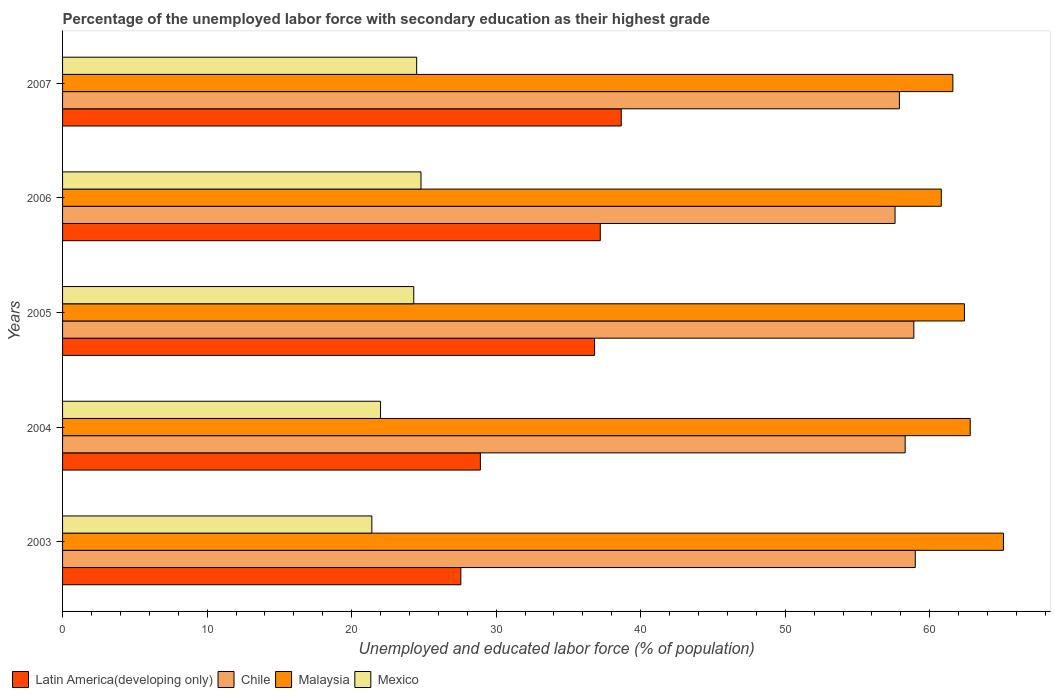How many groups of bars are there?
Offer a terse response. 5. Are the number of bars per tick equal to the number of legend labels?
Provide a succinct answer. Yes. What is the label of the 4th group of bars from the top?
Offer a terse response. 2004. What is the percentage of the unemployed labor force with secondary education in Latin America(developing only) in 2004?
Your answer should be very brief. 28.91. Across all years, what is the maximum percentage of the unemployed labor force with secondary education in Chile?
Make the answer very short. 59. Across all years, what is the minimum percentage of the unemployed labor force with secondary education in Malaysia?
Provide a short and direct response. 60.8. In which year was the percentage of the unemployed labor force with secondary education in Chile minimum?
Provide a short and direct response. 2006. What is the total percentage of the unemployed labor force with secondary education in Chile in the graph?
Offer a terse response. 291.7. What is the difference between the percentage of the unemployed labor force with secondary education in Chile in 2004 and that in 2006?
Keep it short and to the point. 0.7. What is the difference between the percentage of the unemployed labor force with secondary education in Latin America(developing only) in 2005 and the percentage of the unemployed labor force with secondary education in Chile in 2003?
Give a very brief answer. -22.19. What is the average percentage of the unemployed labor force with secondary education in Chile per year?
Offer a very short reply. 58.34. In the year 2005, what is the difference between the percentage of the unemployed labor force with secondary education in Mexico and percentage of the unemployed labor force with secondary education in Latin America(developing only)?
Ensure brevity in your answer.  -12.51. What is the ratio of the percentage of the unemployed labor force with secondary education in Chile in 2005 to that in 2007?
Keep it short and to the point. 1.02. Is the percentage of the unemployed labor force with secondary education in Mexico in 2003 less than that in 2005?
Your response must be concise. Yes. What is the difference between the highest and the second highest percentage of the unemployed labor force with secondary education in Chile?
Your answer should be compact. 0.1. What is the difference between the highest and the lowest percentage of the unemployed labor force with secondary education in Latin America(developing only)?
Your answer should be very brief. 11.1. Is it the case that in every year, the sum of the percentage of the unemployed labor force with secondary education in Malaysia and percentage of the unemployed labor force with secondary education in Chile is greater than the sum of percentage of the unemployed labor force with secondary education in Mexico and percentage of the unemployed labor force with secondary education in Latin America(developing only)?
Give a very brief answer. Yes. What does the 3rd bar from the top in 2005 represents?
Provide a short and direct response. Chile. What does the 1st bar from the bottom in 2005 represents?
Your answer should be compact. Latin America(developing only). How many bars are there?
Offer a very short reply. 20. Are all the bars in the graph horizontal?
Offer a very short reply. Yes. Are the values on the major ticks of X-axis written in scientific E-notation?
Keep it short and to the point. No. Does the graph contain grids?
Make the answer very short. No. How many legend labels are there?
Your answer should be very brief. 4. What is the title of the graph?
Provide a short and direct response. Percentage of the unemployed labor force with secondary education as their highest grade. Does "Gambia, The" appear as one of the legend labels in the graph?
Offer a terse response. No. What is the label or title of the X-axis?
Give a very brief answer. Unemployed and educated labor force (% of population). What is the Unemployed and educated labor force (% of population) in Latin America(developing only) in 2003?
Provide a succinct answer. 27.56. What is the Unemployed and educated labor force (% of population) of Malaysia in 2003?
Keep it short and to the point. 65.1. What is the Unemployed and educated labor force (% of population) of Mexico in 2003?
Your answer should be very brief. 21.4. What is the Unemployed and educated labor force (% of population) of Latin America(developing only) in 2004?
Offer a very short reply. 28.91. What is the Unemployed and educated labor force (% of population) in Chile in 2004?
Ensure brevity in your answer.  58.3. What is the Unemployed and educated labor force (% of population) of Malaysia in 2004?
Your answer should be very brief. 62.8. What is the Unemployed and educated labor force (% of population) in Latin America(developing only) in 2005?
Offer a very short reply. 36.81. What is the Unemployed and educated labor force (% of population) in Chile in 2005?
Your answer should be compact. 58.9. What is the Unemployed and educated labor force (% of population) in Malaysia in 2005?
Keep it short and to the point. 62.4. What is the Unemployed and educated labor force (% of population) in Mexico in 2005?
Offer a very short reply. 24.3. What is the Unemployed and educated labor force (% of population) in Latin America(developing only) in 2006?
Offer a very short reply. 37.21. What is the Unemployed and educated labor force (% of population) in Chile in 2006?
Ensure brevity in your answer.  57.6. What is the Unemployed and educated labor force (% of population) of Malaysia in 2006?
Your response must be concise. 60.8. What is the Unemployed and educated labor force (% of population) of Mexico in 2006?
Your response must be concise. 24.8. What is the Unemployed and educated labor force (% of population) of Latin America(developing only) in 2007?
Your answer should be very brief. 38.66. What is the Unemployed and educated labor force (% of population) in Chile in 2007?
Offer a very short reply. 57.9. What is the Unemployed and educated labor force (% of population) in Malaysia in 2007?
Your answer should be very brief. 61.6. Across all years, what is the maximum Unemployed and educated labor force (% of population) of Latin America(developing only)?
Your answer should be very brief. 38.66. Across all years, what is the maximum Unemployed and educated labor force (% of population) in Malaysia?
Give a very brief answer. 65.1. Across all years, what is the maximum Unemployed and educated labor force (% of population) in Mexico?
Keep it short and to the point. 24.8. Across all years, what is the minimum Unemployed and educated labor force (% of population) in Latin America(developing only)?
Give a very brief answer. 27.56. Across all years, what is the minimum Unemployed and educated labor force (% of population) in Chile?
Offer a very short reply. 57.6. Across all years, what is the minimum Unemployed and educated labor force (% of population) of Malaysia?
Your answer should be compact. 60.8. Across all years, what is the minimum Unemployed and educated labor force (% of population) of Mexico?
Provide a succinct answer. 21.4. What is the total Unemployed and educated labor force (% of population) of Latin America(developing only) in the graph?
Keep it short and to the point. 169.14. What is the total Unemployed and educated labor force (% of population) in Chile in the graph?
Make the answer very short. 291.7. What is the total Unemployed and educated labor force (% of population) of Malaysia in the graph?
Provide a short and direct response. 312.7. What is the total Unemployed and educated labor force (% of population) of Mexico in the graph?
Offer a very short reply. 117. What is the difference between the Unemployed and educated labor force (% of population) of Latin America(developing only) in 2003 and that in 2004?
Your response must be concise. -1.35. What is the difference between the Unemployed and educated labor force (% of population) in Malaysia in 2003 and that in 2004?
Ensure brevity in your answer.  2.3. What is the difference between the Unemployed and educated labor force (% of population) in Mexico in 2003 and that in 2004?
Keep it short and to the point. -0.6. What is the difference between the Unemployed and educated labor force (% of population) in Latin America(developing only) in 2003 and that in 2005?
Offer a very short reply. -9.25. What is the difference between the Unemployed and educated labor force (% of population) in Latin America(developing only) in 2003 and that in 2006?
Provide a succinct answer. -9.65. What is the difference between the Unemployed and educated labor force (% of population) of Chile in 2003 and that in 2006?
Offer a very short reply. 1.4. What is the difference between the Unemployed and educated labor force (% of population) in Malaysia in 2003 and that in 2006?
Make the answer very short. 4.3. What is the difference between the Unemployed and educated labor force (% of population) of Latin America(developing only) in 2003 and that in 2007?
Provide a succinct answer. -11.1. What is the difference between the Unemployed and educated labor force (% of population) in Chile in 2003 and that in 2007?
Offer a terse response. 1.1. What is the difference between the Unemployed and educated labor force (% of population) of Mexico in 2003 and that in 2007?
Make the answer very short. -3.1. What is the difference between the Unemployed and educated labor force (% of population) of Latin America(developing only) in 2004 and that in 2005?
Make the answer very short. -7.9. What is the difference between the Unemployed and educated labor force (% of population) in Malaysia in 2004 and that in 2005?
Ensure brevity in your answer.  0.4. What is the difference between the Unemployed and educated labor force (% of population) in Latin America(developing only) in 2004 and that in 2006?
Offer a very short reply. -8.3. What is the difference between the Unemployed and educated labor force (% of population) in Chile in 2004 and that in 2006?
Offer a terse response. 0.7. What is the difference between the Unemployed and educated labor force (% of population) in Malaysia in 2004 and that in 2006?
Give a very brief answer. 2. What is the difference between the Unemployed and educated labor force (% of population) in Mexico in 2004 and that in 2006?
Keep it short and to the point. -2.8. What is the difference between the Unemployed and educated labor force (% of population) of Latin America(developing only) in 2004 and that in 2007?
Ensure brevity in your answer.  -9.75. What is the difference between the Unemployed and educated labor force (% of population) of Latin America(developing only) in 2005 and that in 2006?
Offer a terse response. -0.39. What is the difference between the Unemployed and educated labor force (% of population) in Mexico in 2005 and that in 2006?
Your response must be concise. -0.5. What is the difference between the Unemployed and educated labor force (% of population) of Latin America(developing only) in 2005 and that in 2007?
Keep it short and to the point. -1.84. What is the difference between the Unemployed and educated labor force (% of population) in Mexico in 2005 and that in 2007?
Make the answer very short. -0.2. What is the difference between the Unemployed and educated labor force (% of population) of Latin America(developing only) in 2006 and that in 2007?
Ensure brevity in your answer.  -1.45. What is the difference between the Unemployed and educated labor force (% of population) in Malaysia in 2006 and that in 2007?
Your answer should be compact. -0.8. What is the difference between the Unemployed and educated labor force (% of population) of Latin America(developing only) in 2003 and the Unemployed and educated labor force (% of population) of Chile in 2004?
Provide a succinct answer. -30.74. What is the difference between the Unemployed and educated labor force (% of population) of Latin America(developing only) in 2003 and the Unemployed and educated labor force (% of population) of Malaysia in 2004?
Offer a terse response. -35.24. What is the difference between the Unemployed and educated labor force (% of population) of Latin America(developing only) in 2003 and the Unemployed and educated labor force (% of population) of Mexico in 2004?
Ensure brevity in your answer.  5.56. What is the difference between the Unemployed and educated labor force (% of population) in Malaysia in 2003 and the Unemployed and educated labor force (% of population) in Mexico in 2004?
Make the answer very short. 43.1. What is the difference between the Unemployed and educated labor force (% of population) of Latin America(developing only) in 2003 and the Unemployed and educated labor force (% of population) of Chile in 2005?
Provide a succinct answer. -31.34. What is the difference between the Unemployed and educated labor force (% of population) of Latin America(developing only) in 2003 and the Unemployed and educated labor force (% of population) of Malaysia in 2005?
Ensure brevity in your answer.  -34.84. What is the difference between the Unemployed and educated labor force (% of population) of Latin America(developing only) in 2003 and the Unemployed and educated labor force (% of population) of Mexico in 2005?
Make the answer very short. 3.26. What is the difference between the Unemployed and educated labor force (% of population) of Chile in 2003 and the Unemployed and educated labor force (% of population) of Malaysia in 2005?
Your response must be concise. -3.4. What is the difference between the Unemployed and educated labor force (% of population) of Chile in 2003 and the Unemployed and educated labor force (% of population) of Mexico in 2005?
Make the answer very short. 34.7. What is the difference between the Unemployed and educated labor force (% of population) of Malaysia in 2003 and the Unemployed and educated labor force (% of population) of Mexico in 2005?
Your response must be concise. 40.8. What is the difference between the Unemployed and educated labor force (% of population) of Latin America(developing only) in 2003 and the Unemployed and educated labor force (% of population) of Chile in 2006?
Provide a succinct answer. -30.04. What is the difference between the Unemployed and educated labor force (% of population) of Latin America(developing only) in 2003 and the Unemployed and educated labor force (% of population) of Malaysia in 2006?
Ensure brevity in your answer.  -33.24. What is the difference between the Unemployed and educated labor force (% of population) in Latin America(developing only) in 2003 and the Unemployed and educated labor force (% of population) in Mexico in 2006?
Make the answer very short. 2.76. What is the difference between the Unemployed and educated labor force (% of population) of Chile in 2003 and the Unemployed and educated labor force (% of population) of Mexico in 2006?
Provide a succinct answer. 34.2. What is the difference between the Unemployed and educated labor force (% of population) in Malaysia in 2003 and the Unemployed and educated labor force (% of population) in Mexico in 2006?
Offer a very short reply. 40.3. What is the difference between the Unemployed and educated labor force (% of population) in Latin America(developing only) in 2003 and the Unemployed and educated labor force (% of population) in Chile in 2007?
Your response must be concise. -30.34. What is the difference between the Unemployed and educated labor force (% of population) in Latin America(developing only) in 2003 and the Unemployed and educated labor force (% of population) in Malaysia in 2007?
Provide a succinct answer. -34.04. What is the difference between the Unemployed and educated labor force (% of population) in Latin America(developing only) in 2003 and the Unemployed and educated labor force (% of population) in Mexico in 2007?
Provide a succinct answer. 3.06. What is the difference between the Unemployed and educated labor force (% of population) of Chile in 2003 and the Unemployed and educated labor force (% of population) of Mexico in 2007?
Provide a succinct answer. 34.5. What is the difference between the Unemployed and educated labor force (% of population) in Malaysia in 2003 and the Unemployed and educated labor force (% of population) in Mexico in 2007?
Offer a very short reply. 40.6. What is the difference between the Unemployed and educated labor force (% of population) in Latin America(developing only) in 2004 and the Unemployed and educated labor force (% of population) in Chile in 2005?
Your answer should be compact. -29.99. What is the difference between the Unemployed and educated labor force (% of population) of Latin America(developing only) in 2004 and the Unemployed and educated labor force (% of population) of Malaysia in 2005?
Offer a very short reply. -33.49. What is the difference between the Unemployed and educated labor force (% of population) of Latin America(developing only) in 2004 and the Unemployed and educated labor force (% of population) of Mexico in 2005?
Offer a very short reply. 4.61. What is the difference between the Unemployed and educated labor force (% of population) of Malaysia in 2004 and the Unemployed and educated labor force (% of population) of Mexico in 2005?
Ensure brevity in your answer.  38.5. What is the difference between the Unemployed and educated labor force (% of population) in Latin America(developing only) in 2004 and the Unemployed and educated labor force (% of population) in Chile in 2006?
Make the answer very short. -28.69. What is the difference between the Unemployed and educated labor force (% of population) in Latin America(developing only) in 2004 and the Unemployed and educated labor force (% of population) in Malaysia in 2006?
Give a very brief answer. -31.89. What is the difference between the Unemployed and educated labor force (% of population) in Latin America(developing only) in 2004 and the Unemployed and educated labor force (% of population) in Mexico in 2006?
Keep it short and to the point. 4.11. What is the difference between the Unemployed and educated labor force (% of population) of Chile in 2004 and the Unemployed and educated labor force (% of population) of Malaysia in 2006?
Give a very brief answer. -2.5. What is the difference between the Unemployed and educated labor force (% of population) in Chile in 2004 and the Unemployed and educated labor force (% of population) in Mexico in 2006?
Provide a short and direct response. 33.5. What is the difference between the Unemployed and educated labor force (% of population) in Latin America(developing only) in 2004 and the Unemployed and educated labor force (% of population) in Chile in 2007?
Provide a short and direct response. -28.99. What is the difference between the Unemployed and educated labor force (% of population) of Latin America(developing only) in 2004 and the Unemployed and educated labor force (% of population) of Malaysia in 2007?
Your answer should be compact. -32.69. What is the difference between the Unemployed and educated labor force (% of population) in Latin America(developing only) in 2004 and the Unemployed and educated labor force (% of population) in Mexico in 2007?
Make the answer very short. 4.41. What is the difference between the Unemployed and educated labor force (% of population) in Chile in 2004 and the Unemployed and educated labor force (% of population) in Mexico in 2007?
Your answer should be very brief. 33.8. What is the difference between the Unemployed and educated labor force (% of population) in Malaysia in 2004 and the Unemployed and educated labor force (% of population) in Mexico in 2007?
Ensure brevity in your answer.  38.3. What is the difference between the Unemployed and educated labor force (% of population) of Latin America(developing only) in 2005 and the Unemployed and educated labor force (% of population) of Chile in 2006?
Your answer should be compact. -20.79. What is the difference between the Unemployed and educated labor force (% of population) in Latin America(developing only) in 2005 and the Unemployed and educated labor force (% of population) in Malaysia in 2006?
Provide a succinct answer. -23.99. What is the difference between the Unemployed and educated labor force (% of population) in Latin America(developing only) in 2005 and the Unemployed and educated labor force (% of population) in Mexico in 2006?
Offer a terse response. 12.01. What is the difference between the Unemployed and educated labor force (% of population) of Chile in 2005 and the Unemployed and educated labor force (% of population) of Mexico in 2006?
Your response must be concise. 34.1. What is the difference between the Unemployed and educated labor force (% of population) in Malaysia in 2005 and the Unemployed and educated labor force (% of population) in Mexico in 2006?
Your answer should be very brief. 37.6. What is the difference between the Unemployed and educated labor force (% of population) of Latin America(developing only) in 2005 and the Unemployed and educated labor force (% of population) of Chile in 2007?
Keep it short and to the point. -21.09. What is the difference between the Unemployed and educated labor force (% of population) in Latin America(developing only) in 2005 and the Unemployed and educated labor force (% of population) in Malaysia in 2007?
Offer a terse response. -24.79. What is the difference between the Unemployed and educated labor force (% of population) of Latin America(developing only) in 2005 and the Unemployed and educated labor force (% of population) of Mexico in 2007?
Your answer should be very brief. 12.31. What is the difference between the Unemployed and educated labor force (% of population) in Chile in 2005 and the Unemployed and educated labor force (% of population) in Mexico in 2007?
Your answer should be compact. 34.4. What is the difference between the Unemployed and educated labor force (% of population) in Malaysia in 2005 and the Unemployed and educated labor force (% of population) in Mexico in 2007?
Keep it short and to the point. 37.9. What is the difference between the Unemployed and educated labor force (% of population) of Latin America(developing only) in 2006 and the Unemployed and educated labor force (% of population) of Chile in 2007?
Provide a short and direct response. -20.69. What is the difference between the Unemployed and educated labor force (% of population) of Latin America(developing only) in 2006 and the Unemployed and educated labor force (% of population) of Malaysia in 2007?
Ensure brevity in your answer.  -24.39. What is the difference between the Unemployed and educated labor force (% of population) in Latin America(developing only) in 2006 and the Unemployed and educated labor force (% of population) in Mexico in 2007?
Offer a terse response. 12.71. What is the difference between the Unemployed and educated labor force (% of population) in Chile in 2006 and the Unemployed and educated labor force (% of population) in Mexico in 2007?
Make the answer very short. 33.1. What is the difference between the Unemployed and educated labor force (% of population) of Malaysia in 2006 and the Unemployed and educated labor force (% of population) of Mexico in 2007?
Ensure brevity in your answer.  36.3. What is the average Unemployed and educated labor force (% of population) of Latin America(developing only) per year?
Keep it short and to the point. 33.83. What is the average Unemployed and educated labor force (% of population) in Chile per year?
Your answer should be very brief. 58.34. What is the average Unemployed and educated labor force (% of population) of Malaysia per year?
Make the answer very short. 62.54. What is the average Unemployed and educated labor force (% of population) in Mexico per year?
Ensure brevity in your answer.  23.4. In the year 2003, what is the difference between the Unemployed and educated labor force (% of population) in Latin America(developing only) and Unemployed and educated labor force (% of population) in Chile?
Ensure brevity in your answer.  -31.44. In the year 2003, what is the difference between the Unemployed and educated labor force (% of population) in Latin America(developing only) and Unemployed and educated labor force (% of population) in Malaysia?
Your answer should be very brief. -37.54. In the year 2003, what is the difference between the Unemployed and educated labor force (% of population) of Latin America(developing only) and Unemployed and educated labor force (% of population) of Mexico?
Your answer should be compact. 6.16. In the year 2003, what is the difference between the Unemployed and educated labor force (% of population) of Chile and Unemployed and educated labor force (% of population) of Mexico?
Provide a short and direct response. 37.6. In the year 2003, what is the difference between the Unemployed and educated labor force (% of population) in Malaysia and Unemployed and educated labor force (% of population) in Mexico?
Keep it short and to the point. 43.7. In the year 2004, what is the difference between the Unemployed and educated labor force (% of population) in Latin America(developing only) and Unemployed and educated labor force (% of population) in Chile?
Offer a very short reply. -29.39. In the year 2004, what is the difference between the Unemployed and educated labor force (% of population) of Latin America(developing only) and Unemployed and educated labor force (% of population) of Malaysia?
Give a very brief answer. -33.89. In the year 2004, what is the difference between the Unemployed and educated labor force (% of population) of Latin America(developing only) and Unemployed and educated labor force (% of population) of Mexico?
Keep it short and to the point. 6.91. In the year 2004, what is the difference between the Unemployed and educated labor force (% of population) of Chile and Unemployed and educated labor force (% of population) of Mexico?
Provide a succinct answer. 36.3. In the year 2004, what is the difference between the Unemployed and educated labor force (% of population) of Malaysia and Unemployed and educated labor force (% of population) of Mexico?
Your response must be concise. 40.8. In the year 2005, what is the difference between the Unemployed and educated labor force (% of population) in Latin America(developing only) and Unemployed and educated labor force (% of population) in Chile?
Your answer should be compact. -22.09. In the year 2005, what is the difference between the Unemployed and educated labor force (% of population) of Latin America(developing only) and Unemployed and educated labor force (% of population) of Malaysia?
Your answer should be compact. -25.59. In the year 2005, what is the difference between the Unemployed and educated labor force (% of population) in Latin America(developing only) and Unemployed and educated labor force (% of population) in Mexico?
Offer a very short reply. 12.51. In the year 2005, what is the difference between the Unemployed and educated labor force (% of population) of Chile and Unemployed and educated labor force (% of population) of Malaysia?
Your answer should be very brief. -3.5. In the year 2005, what is the difference between the Unemployed and educated labor force (% of population) of Chile and Unemployed and educated labor force (% of population) of Mexico?
Offer a very short reply. 34.6. In the year 2005, what is the difference between the Unemployed and educated labor force (% of population) in Malaysia and Unemployed and educated labor force (% of population) in Mexico?
Your answer should be compact. 38.1. In the year 2006, what is the difference between the Unemployed and educated labor force (% of population) of Latin America(developing only) and Unemployed and educated labor force (% of population) of Chile?
Provide a short and direct response. -20.39. In the year 2006, what is the difference between the Unemployed and educated labor force (% of population) of Latin America(developing only) and Unemployed and educated labor force (% of population) of Malaysia?
Provide a short and direct response. -23.59. In the year 2006, what is the difference between the Unemployed and educated labor force (% of population) in Latin America(developing only) and Unemployed and educated labor force (% of population) in Mexico?
Your answer should be compact. 12.41. In the year 2006, what is the difference between the Unemployed and educated labor force (% of population) of Chile and Unemployed and educated labor force (% of population) of Mexico?
Your answer should be compact. 32.8. In the year 2007, what is the difference between the Unemployed and educated labor force (% of population) of Latin America(developing only) and Unemployed and educated labor force (% of population) of Chile?
Offer a terse response. -19.24. In the year 2007, what is the difference between the Unemployed and educated labor force (% of population) in Latin America(developing only) and Unemployed and educated labor force (% of population) in Malaysia?
Your answer should be compact. -22.94. In the year 2007, what is the difference between the Unemployed and educated labor force (% of population) of Latin America(developing only) and Unemployed and educated labor force (% of population) of Mexico?
Your answer should be compact. 14.16. In the year 2007, what is the difference between the Unemployed and educated labor force (% of population) of Chile and Unemployed and educated labor force (% of population) of Mexico?
Provide a succinct answer. 33.4. In the year 2007, what is the difference between the Unemployed and educated labor force (% of population) of Malaysia and Unemployed and educated labor force (% of population) of Mexico?
Give a very brief answer. 37.1. What is the ratio of the Unemployed and educated labor force (% of population) in Latin America(developing only) in 2003 to that in 2004?
Keep it short and to the point. 0.95. What is the ratio of the Unemployed and educated labor force (% of population) in Chile in 2003 to that in 2004?
Your answer should be compact. 1.01. What is the ratio of the Unemployed and educated labor force (% of population) of Malaysia in 2003 to that in 2004?
Offer a terse response. 1.04. What is the ratio of the Unemployed and educated labor force (% of population) of Mexico in 2003 to that in 2004?
Provide a short and direct response. 0.97. What is the ratio of the Unemployed and educated labor force (% of population) in Latin America(developing only) in 2003 to that in 2005?
Provide a short and direct response. 0.75. What is the ratio of the Unemployed and educated labor force (% of population) in Chile in 2003 to that in 2005?
Your answer should be compact. 1. What is the ratio of the Unemployed and educated labor force (% of population) of Malaysia in 2003 to that in 2005?
Offer a very short reply. 1.04. What is the ratio of the Unemployed and educated labor force (% of population) in Mexico in 2003 to that in 2005?
Offer a very short reply. 0.88. What is the ratio of the Unemployed and educated labor force (% of population) in Latin America(developing only) in 2003 to that in 2006?
Make the answer very short. 0.74. What is the ratio of the Unemployed and educated labor force (% of population) in Chile in 2003 to that in 2006?
Keep it short and to the point. 1.02. What is the ratio of the Unemployed and educated labor force (% of population) of Malaysia in 2003 to that in 2006?
Offer a terse response. 1.07. What is the ratio of the Unemployed and educated labor force (% of population) of Mexico in 2003 to that in 2006?
Offer a very short reply. 0.86. What is the ratio of the Unemployed and educated labor force (% of population) of Latin America(developing only) in 2003 to that in 2007?
Your answer should be very brief. 0.71. What is the ratio of the Unemployed and educated labor force (% of population) of Malaysia in 2003 to that in 2007?
Your answer should be compact. 1.06. What is the ratio of the Unemployed and educated labor force (% of population) in Mexico in 2003 to that in 2007?
Offer a very short reply. 0.87. What is the ratio of the Unemployed and educated labor force (% of population) of Latin America(developing only) in 2004 to that in 2005?
Provide a short and direct response. 0.79. What is the ratio of the Unemployed and educated labor force (% of population) of Malaysia in 2004 to that in 2005?
Your answer should be very brief. 1.01. What is the ratio of the Unemployed and educated labor force (% of population) in Mexico in 2004 to that in 2005?
Provide a short and direct response. 0.91. What is the ratio of the Unemployed and educated labor force (% of population) in Latin America(developing only) in 2004 to that in 2006?
Ensure brevity in your answer.  0.78. What is the ratio of the Unemployed and educated labor force (% of population) in Chile in 2004 to that in 2006?
Offer a terse response. 1.01. What is the ratio of the Unemployed and educated labor force (% of population) of Malaysia in 2004 to that in 2006?
Your answer should be compact. 1.03. What is the ratio of the Unemployed and educated labor force (% of population) in Mexico in 2004 to that in 2006?
Your answer should be very brief. 0.89. What is the ratio of the Unemployed and educated labor force (% of population) in Latin America(developing only) in 2004 to that in 2007?
Make the answer very short. 0.75. What is the ratio of the Unemployed and educated labor force (% of population) in Chile in 2004 to that in 2007?
Make the answer very short. 1.01. What is the ratio of the Unemployed and educated labor force (% of population) in Malaysia in 2004 to that in 2007?
Give a very brief answer. 1.02. What is the ratio of the Unemployed and educated labor force (% of population) in Mexico in 2004 to that in 2007?
Offer a very short reply. 0.9. What is the ratio of the Unemployed and educated labor force (% of population) of Chile in 2005 to that in 2006?
Offer a very short reply. 1.02. What is the ratio of the Unemployed and educated labor force (% of population) in Malaysia in 2005 to that in 2006?
Your answer should be compact. 1.03. What is the ratio of the Unemployed and educated labor force (% of population) of Mexico in 2005 to that in 2006?
Give a very brief answer. 0.98. What is the ratio of the Unemployed and educated labor force (% of population) of Latin America(developing only) in 2005 to that in 2007?
Keep it short and to the point. 0.95. What is the ratio of the Unemployed and educated labor force (% of population) of Chile in 2005 to that in 2007?
Make the answer very short. 1.02. What is the ratio of the Unemployed and educated labor force (% of population) of Malaysia in 2005 to that in 2007?
Give a very brief answer. 1.01. What is the ratio of the Unemployed and educated labor force (% of population) of Latin America(developing only) in 2006 to that in 2007?
Offer a terse response. 0.96. What is the ratio of the Unemployed and educated labor force (% of population) in Chile in 2006 to that in 2007?
Make the answer very short. 0.99. What is the ratio of the Unemployed and educated labor force (% of population) of Mexico in 2006 to that in 2007?
Offer a very short reply. 1.01. What is the difference between the highest and the second highest Unemployed and educated labor force (% of population) in Latin America(developing only)?
Keep it short and to the point. 1.45. What is the difference between the highest and the second highest Unemployed and educated labor force (% of population) in Chile?
Keep it short and to the point. 0.1. What is the difference between the highest and the second highest Unemployed and educated labor force (% of population) of Mexico?
Make the answer very short. 0.3. What is the difference between the highest and the lowest Unemployed and educated labor force (% of population) of Latin America(developing only)?
Your answer should be compact. 11.1. What is the difference between the highest and the lowest Unemployed and educated labor force (% of population) of Chile?
Offer a very short reply. 1.4. What is the difference between the highest and the lowest Unemployed and educated labor force (% of population) of Malaysia?
Provide a succinct answer. 4.3. 